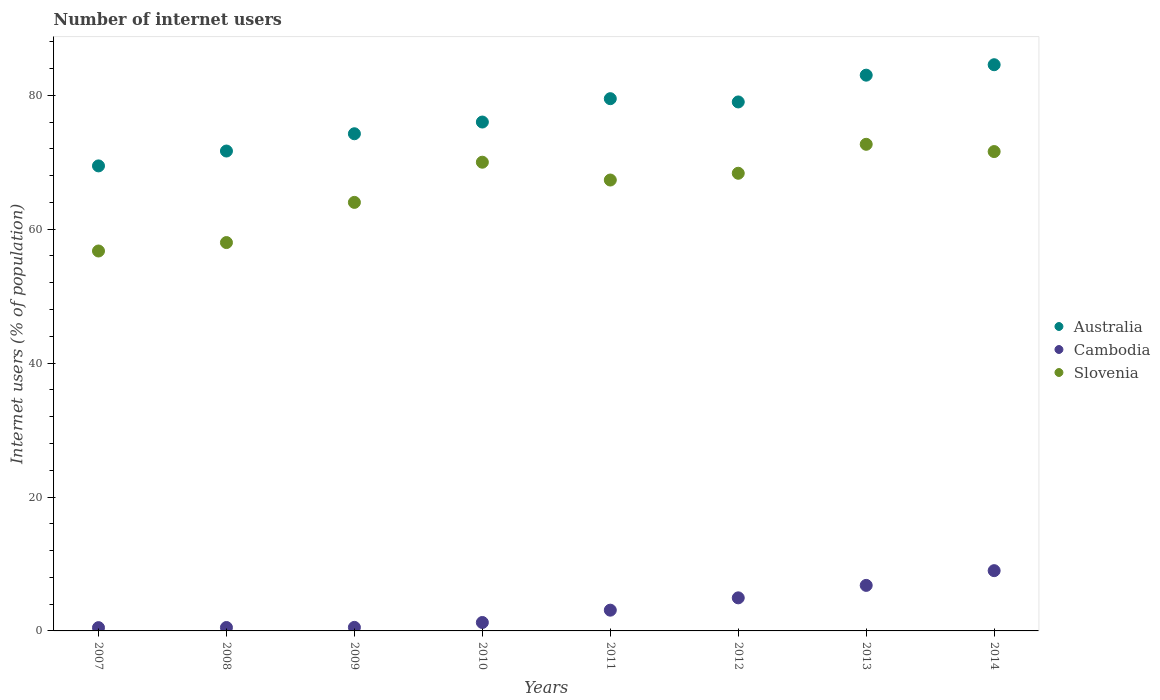Across all years, what is the maximum number of internet users in Australia?
Give a very brief answer. 84.56. Across all years, what is the minimum number of internet users in Cambodia?
Give a very brief answer. 0.49. In which year was the number of internet users in Cambodia maximum?
Your answer should be very brief. 2014. What is the total number of internet users in Cambodia in the graph?
Your response must be concise. 26.63. What is the difference between the number of internet users in Slovenia in 2011 and that in 2013?
Provide a short and direct response. -5.34. What is the difference between the number of internet users in Cambodia in 2007 and the number of internet users in Australia in 2008?
Provide a succinct answer. -71.18. What is the average number of internet users in Slovenia per year?
Your answer should be very brief. 66.09. In the year 2013, what is the difference between the number of internet users in Australia and number of internet users in Slovenia?
Offer a terse response. 10.32. What is the ratio of the number of internet users in Slovenia in 2010 to that in 2013?
Provide a short and direct response. 0.96. Is the number of internet users in Slovenia in 2008 less than that in 2009?
Keep it short and to the point. Yes. Is the difference between the number of internet users in Australia in 2010 and 2014 greater than the difference between the number of internet users in Slovenia in 2010 and 2014?
Offer a very short reply. No. What is the difference between the highest and the second highest number of internet users in Slovenia?
Make the answer very short. 1.09. What is the difference between the highest and the lowest number of internet users in Cambodia?
Your answer should be compact. 8.51. In how many years, is the number of internet users in Cambodia greater than the average number of internet users in Cambodia taken over all years?
Offer a terse response. 3. Is the sum of the number of internet users in Slovenia in 2013 and 2014 greater than the maximum number of internet users in Australia across all years?
Keep it short and to the point. Yes. Does the graph contain grids?
Provide a short and direct response. No. Where does the legend appear in the graph?
Offer a terse response. Center right. How many legend labels are there?
Make the answer very short. 3. What is the title of the graph?
Make the answer very short. Number of internet users. Does "Barbados" appear as one of the legend labels in the graph?
Provide a short and direct response. No. What is the label or title of the X-axis?
Your response must be concise. Years. What is the label or title of the Y-axis?
Ensure brevity in your answer.  Internet users (% of population). What is the Internet users (% of population) of Australia in 2007?
Your response must be concise. 69.45. What is the Internet users (% of population) of Cambodia in 2007?
Provide a short and direct response. 0.49. What is the Internet users (% of population) in Slovenia in 2007?
Give a very brief answer. 56.74. What is the Internet users (% of population) of Australia in 2008?
Provide a short and direct response. 71.67. What is the Internet users (% of population) in Cambodia in 2008?
Your answer should be compact. 0.51. What is the Internet users (% of population) of Slovenia in 2008?
Your answer should be very brief. 58. What is the Internet users (% of population) in Australia in 2009?
Provide a short and direct response. 74.25. What is the Internet users (% of population) of Cambodia in 2009?
Offer a very short reply. 0.53. What is the Internet users (% of population) in Slovenia in 2009?
Keep it short and to the point. 64. What is the Internet users (% of population) of Cambodia in 2010?
Give a very brief answer. 1.26. What is the Internet users (% of population) in Australia in 2011?
Offer a very short reply. 79.49. What is the Internet users (% of population) of Cambodia in 2011?
Make the answer very short. 3.1. What is the Internet users (% of population) of Slovenia in 2011?
Your answer should be compact. 67.34. What is the Internet users (% of population) of Australia in 2012?
Ensure brevity in your answer.  79. What is the Internet users (% of population) of Cambodia in 2012?
Keep it short and to the point. 4.94. What is the Internet users (% of population) of Slovenia in 2012?
Provide a succinct answer. 68.35. What is the Internet users (% of population) of Slovenia in 2013?
Your answer should be compact. 72.68. What is the Internet users (% of population) of Australia in 2014?
Your response must be concise. 84.56. What is the Internet users (% of population) in Cambodia in 2014?
Provide a short and direct response. 9. What is the Internet users (% of population) of Slovenia in 2014?
Your answer should be very brief. 71.59. Across all years, what is the maximum Internet users (% of population) of Australia?
Make the answer very short. 84.56. Across all years, what is the maximum Internet users (% of population) in Slovenia?
Offer a very short reply. 72.68. Across all years, what is the minimum Internet users (% of population) of Australia?
Provide a succinct answer. 69.45. Across all years, what is the minimum Internet users (% of population) in Cambodia?
Your answer should be very brief. 0.49. Across all years, what is the minimum Internet users (% of population) of Slovenia?
Provide a short and direct response. 56.74. What is the total Internet users (% of population) in Australia in the graph?
Provide a short and direct response. 617.42. What is the total Internet users (% of population) of Cambodia in the graph?
Offer a very short reply. 26.63. What is the total Internet users (% of population) in Slovenia in the graph?
Provide a short and direct response. 528.7. What is the difference between the Internet users (% of population) of Australia in 2007 and that in 2008?
Make the answer very short. -2.22. What is the difference between the Internet users (% of population) of Cambodia in 2007 and that in 2008?
Provide a short and direct response. -0.02. What is the difference between the Internet users (% of population) of Slovenia in 2007 and that in 2008?
Ensure brevity in your answer.  -1.26. What is the difference between the Internet users (% of population) in Australia in 2007 and that in 2009?
Make the answer very short. -4.8. What is the difference between the Internet users (% of population) of Cambodia in 2007 and that in 2009?
Provide a succinct answer. -0.04. What is the difference between the Internet users (% of population) in Slovenia in 2007 and that in 2009?
Ensure brevity in your answer.  -7.26. What is the difference between the Internet users (% of population) of Australia in 2007 and that in 2010?
Your response must be concise. -6.55. What is the difference between the Internet users (% of population) in Cambodia in 2007 and that in 2010?
Provide a succinct answer. -0.77. What is the difference between the Internet users (% of population) of Slovenia in 2007 and that in 2010?
Your answer should be very brief. -13.26. What is the difference between the Internet users (% of population) in Australia in 2007 and that in 2011?
Keep it short and to the point. -10.04. What is the difference between the Internet users (% of population) of Cambodia in 2007 and that in 2011?
Provide a short and direct response. -2.61. What is the difference between the Internet users (% of population) of Slovenia in 2007 and that in 2011?
Your answer should be very brief. -10.6. What is the difference between the Internet users (% of population) of Australia in 2007 and that in 2012?
Your answer should be very brief. -9.55. What is the difference between the Internet users (% of population) of Cambodia in 2007 and that in 2012?
Give a very brief answer. -4.45. What is the difference between the Internet users (% of population) in Slovenia in 2007 and that in 2012?
Your response must be concise. -11.61. What is the difference between the Internet users (% of population) in Australia in 2007 and that in 2013?
Provide a short and direct response. -13.55. What is the difference between the Internet users (% of population) of Cambodia in 2007 and that in 2013?
Your response must be concise. -6.31. What is the difference between the Internet users (% of population) in Slovenia in 2007 and that in 2013?
Ensure brevity in your answer.  -15.94. What is the difference between the Internet users (% of population) in Australia in 2007 and that in 2014?
Give a very brief answer. -15.11. What is the difference between the Internet users (% of population) in Cambodia in 2007 and that in 2014?
Provide a succinct answer. -8.51. What is the difference between the Internet users (% of population) of Slovenia in 2007 and that in 2014?
Give a very brief answer. -14.85. What is the difference between the Internet users (% of population) in Australia in 2008 and that in 2009?
Make the answer very short. -2.58. What is the difference between the Internet users (% of population) of Cambodia in 2008 and that in 2009?
Make the answer very short. -0.02. What is the difference between the Internet users (% of population) of Slovenia in 2008 and that in 2009?
Provide a short and direct response. -6. What is the difference between the Internet users (% of population) of Australia in 2008 and that in 2010?
Provide a succinct answer. -4.33. What is the difference between the Internet users (% of population) in Cambodia in 2008 and that in 2010?
Offer a terse response. -0.75. What is the difference between the Internet users (% of population) of Slovenia in 2008 and that in 2010?
Give a very brief answer. -12. What is the difference between the Internet users (% of population) of Australia in 2008 and that in 2011?
Keep it short and to the point. -7.82. What is the difference between the Internet users (% of population) of Cambodia in 2008 and that in 2011?
Ensure brevity in your answer.  -2.59. What is the difference between the Internet users (% of population) in Slovenia in 2008 and that in 2011?
Your answer should be compact. -9.34. What is the difference between the Internet users (% of population) in Australia in 2008 and that in 2012?
Your answer should be very brief. -7.33. What is the difference between the Internet users (% of population) of Cambodia in 2008 and that in 2012?
Offer a terse response. -4.43. What is the difference between the Internet users (% of population) in Slovenia in 2008 and that in 2012?
Offer a terse response. -10.35. What is the difference between the Internet users (% of population) in Australia in 2008 and that in 2013?
Offer a very short reply. -11.33. What is the difference between the Internet users (% of population) of Cambodia in 2008 and that in 2013?
Ensure brevity in your answer.  -6.29. What is the difference between the Internet users (% of population) of Slovenia in 2008 and that in 2013?
Ensure brevity in your answer.  -14.68. What is the difference between the Internet users (% of population) of Australia in 2008 and that in 2014?
Give a very brief answer. -12.89. What is the difference between the Internet users (% of population) in Cambodia in 2008 and that in 2014?
Give a very brief answer. -8.49. What is the difference between the Internet users (% of population) of Slovenia in 2008 and that in 2014?
Your response must be concise. -13.59. What is the difference between the Internet users (% of population) of Australia in 2009 and that in 2010?
Provide a succinct answer. -1.75. What is the difference between the Internet users (% of population) in Cambodia in 2009 and that in 2010?
Provide a succinct answer. -0.73. What is the difference between the Internet users (% of population) of Australia in 2009 and that in 2011?
Offer a terse response. -5.24. What is the difference between the Internet users (% of population) in Cambodia in 2009 and that in 2011?
Your response must be concise. -2.57. What is the difference between the Internet users (% of population) in Slovenia in 2009 and that in 2011?
Offer a very short reply. -3.34. What is the difference between the Internet users (% of population) in Australia in 2009 and that in 2012?
Give a very brief answer. -4.75. What is the difference between the Internet users (% of population) in Cambodia in 2009 and that in 2012?
Your response must be concise. -4.41. What is the difference between the Internet users (% of population) of Slovenia in 2009 and that in 2012?
Ensure brevity in your answer.  -4.35. What is the difference between the Internet users (% of population) of Australia in 2009 and that in 2013?
Your answer should be compact. -8.75. What is the difference between the Internet users (% of population) of Cambodia in 2009 and that in 2013?
Your answer should be very brief. -6.27. What is the difference between the Internet users (% of population) in Slovenia in 2009 and that in 2013?
Give a very brief answer. -8.68. What is the difference between the Internet users (% of population) of Australia in 2009 and that in 2014?
Keep it short and to the point. -10.31. What is the difference between the Internet users (% of population) in Cambodia in 2009 and that in 2014?
Keep it short and to the point. -8.47. What is the difference between the Internet users (% of population) in Slovenia in 2009 and that in 2014?
Offer a terse response. -7.59. What is the difference between the Internet users (% of population) of Australia in 2010 and that in 2011?
Provide a succinct answer. -3.49. What is the difference between the Internet users (% of population) in Cambodia in 2010 and that in 2011?
Your answer should be very brief. -1.84. What is the difference between the Internet users (% of population) of Slovenia in 2010 and that in 2011?
Offer a terse response. 2.66. What is the difference between the Internet users (% of population) of Australia in 2010 and that in 2012?
Provide a short and direct response. -3. What is the difference between the Internet users (% of population) in Cambodia in 2010 and that in 2012?
Make the answer very short. -3.68. What is the difference between the Internet users (% of population) of Slovenia in 2010 and that in 2012?
Provide a short and direct response. 1.65. What is the difference between the Internet users (% of population) in Cambodia in 2010 and that in 2013?
Your answer should be compact. -5.54. What is the difference between the Internet users (% of population) of Slovenia in 2010 and that in 2013?
Keep it short and to the point. -2.68. What is the difference between the Internet users (% of population) in Australia in 2010 and that in 2014?
Your answer should be very brief. -8.56. What is the difference between the Internet users (% of population) in Cambodia in 2010 and that in 2014?
Provide a succinct answer. -7.74. What is the difference between the Internet users (% of population) in Slovenia in 2010 and that in 2014?
Your answer should be compact. -1.59. What is the difference between the Internet users (% of population) of Australia in 2011 and that in 2012?
Ensure brevity in your answer.  0.49. What is the difference between the Internet users (% of population) of Cambodia in 2011 and that in 2012?
Your answer should be compact. -1.84. What is the difference between the Internet users (% of population) in Slovenia in 2011 and that in 2012?
Offer a very short reply. -1.01. What is the difference between the Internet users (% of population) of Australia in 2011 and that in 2013?
Your answer should be compact. -3.51. What is the difference between the Internet users (% of population) of Cambodia in 2011 and that in 2013?
Make the answer very short. -3.7. What is the difference between the Internet users (% of population) of Slovenia in 2011 and that in 2013?
Your answer should be very brief. -5.34. What is the difference between the Internet users (% of population) of Australia in 2011 and that in 2014?
Your answer should be compact. -5.07. What is the difference between the Internet users (% of population) in Slovenia in 2011 and that in 2014?
Make the answer very short. -4.25. What is the difference between the Internet users (% of population) in Cambodia in 2012 and that in 2013?
Make the answer very short. -1.86. What is the difference between the Internet users (% of population) in Slovenia in 2012 and that in 2013?
Your response must be concise. -4.33. What is the difference between the Internet users (% of population) in Australia in 2012 and that in 2014?
Give a very brief answer. -5.56. What is the difference between the Internet users (% of population) of Cambodia in 2012 and that in 2014?
Keep it short and to the point. -4.06. What is the difference between the Internet users (% of population) in Slovenia in 2012 and that in 2014?
Your response must be concise. -3.24. What is the difference between the Internet users (% of population) in Australia in 2013 and that in 2014?
Offer a very short reply. -1.56. What is the difference between the Internet users (% of population) in Slovenia in 2013 and that in 2014?
Keep it short and to the point. 1.09. What is the difference between the Internet users (% of population) of Australia in 2007 and the Internet users (% of population) of Cambodia in 2008?
Give a very brief answer. 68.94. What is the difference between the Internet users (% of population) in Australia in 2007 and the Internet users (% of population) in Slovenia in 2008?
Give a very brief answer. 11.45. What is the difference between the Internet users (% of population) of Cambodia in 2007 and the Internet users (% of population) of Slovenia in 2008?
Provide a succinct answer. -57.51. What is the difference between the Internet users (% of population) in Australia in 2007 and the Internet users (% of population) in Cambodia in 2009?
Your answer should be very brief. 68.92. What is the difference between the Internet users (% of population) of Australia in 2007 and the Internet users (% of population) of Slovenia in 2009?
Give a very brief answer. 5.45. What is the difference between the Internet users (% of population) in Cambodia in 2007 and the Internet users (% of population) in Slovenia in 2009?
Your answer should be compact. -63.51. What is the difference between the Internet users (% of population) of Australia in 2007 and the Internet users (% of population) of Cambodia in 2010?
Make the answer very short. 68.19. What is the difference between the Internet users (% of population) of Australia in 2007 and the Internet users (% of population) of Slovenia in 2010?
Offer a very short reply. -0.55. What is the difference between the Internet users (% of population) of Cambodia in 2007 and the Internet users (% of population) of Slovenia in 2010?
Provide a succinct answer. -69.51. What is the difference between the Internet users (% of population) of Australia in 2007 and the Internet users (% of population) of Cambodia in 2011?
Provide a short and direct response. 66.35. What is the difference between the Internet users (% of population) of Australia in 2007 and the Internet users (% of population) of Slovenia in 2011?
Keep it short and to the point. 2.11. What is the difference between the Internet users (% of population) in Cambodia in 2007 and the Internet users (% of population) in Slovenia in 2011?
Offer a very short reply. -66.85. What is the difference between the Internet users (% of population) in Australia in 2007 and the Internet users (% of population) in Cambodia in 2012?
Provide a succinct answer. 64.51. What is the difference between the Internet users (% of population) of Australia in 2007 and the Internet users (% of population) of Slovenia in 2012?
Make the answer very short. 1.1. What is the difference between the Internet users (% of population) in Cambodia in 2007 and the Internet users (% of population) in Slovenia in 2012?
Your answer should be very brief. -67.86. What is the difference between the Internet users (% of population) in Australia in 2007 and the Internet users (% of population) in Cambodia in 2013?
Offer a very short reply. 62.65. What is the difference between the Internet users (% of population) of Australia in 2007 and the Internet users (% of population) of Slovenia in 2013?
Your response must be concise. -3.23. What is the difference between the Internet users (% of population) of Cambodia in 2007 and the Internet users (% of population) of Slovenia in 2013?
Ensure brevity in your answer.  -72.19. What is the difference between the Internet users (% of population) of Australia in 2007 and the Internet users (% of population) of Cambodia in 2014?
Ensure brevity in your answer.  60.45. What is the difference between the Internet users (% of population) in Australia in 2007 and the Internet users (% of population) in Slovenia in 2014?
Ensure brevity in your answer.  -2.14. What is the difference between the Internet users (% of population) of Cambodia in 2007 and the Internet users (% of population) of Slovenia in 2014?
Your response must be concise. -71.1. What is the difference between the Internet users (% of population) of Australia in 2008 and the Internet users (% of population) of Cambodia in 2009?
Your answer should be compact. 71.14. What is the difference between the Internet users (% of population) in Australia in 2008 and the Internet users (% of population) in Slovenia in 2009?
Your response must be concise. 7.67. What is the difference between the Internet users (% of population) in Cambodia in 2008 and the Internet users (% of population) in Slovenia in 2009?
Your answer should be compact. -63.49. What is the difference between the Internet users (% of population) of Australia in 2008 and the Internet users (% of population) of Cambodia in 2010?
Make the answer very short. 70.41. What is the difference between the Internet users (% of population) of Australia in 2008 and the Internet users (% of population) of Slovenia in 2010?
Your answer should be compact. 1.67. What is the difference between the Internet users (% of population) of Cambodia in 2008 and the Internet users (% of population) of Slovenia in 2010?
Offer a very short reply. -69.49. What is the difference between the Internet users (% of population) in Australia in 2008 and the Internet users (% of population) in Cambodia in 2011?
Provide a succinct answer. 68.57. What is the difference between the Internet users (% of population) in Australia in 2008 and the Internet users (% of population) in Slovenia in 2011?
Your answer should be very brief. 4.33. What is the difference between the Internet users (% of population) in Cambodia in 2008 and the Internet users (% of population) in Slovenia in 2011?
Ensure brevity in your answer.  -66.83. What is the difference between the Internet users (% of population) of Australia in 2008 and the Internet users (% of population) of Cambodia in 2012?
Offer a terse response. 66.73. What is the difference between the Internet users (% of population) in Australia in 2008 and the Internet users (% of population) in Slovenia in 2012?
Give a very brief answer. 3.32. What is the difference between the Internet users (% of population) in Cambodia in 2008 and the Internet users (% of population) in Slovenia in 2012?
Provide a short and direct response. -67.84. What is the difference between the Internet users (% of population) of Australia in 2008 and the Internet users (% of population) of Cambodia in 2013?
Offer a terse response. 64.87. What is the difference between the Internet users (% of population) of Australia in 2008 and the Internet users (% of population) of Slovenia in 2013?
Your answer should be compact. -1.01. What is the difference between the Internet users (% of population) of Cambodia in 2008 and the Internet users (% of population) of Slovenia in 2013?
Your answer should be very brief. -72.17. What is the difference between the Internet users (% of population) in Australia in 2008 and the Internet users (% of population) in Cambodia in 2014?
Provide a succinct answer. 62.67. What is the difference between the Internet users (% of population) in Cambodia in 2008 and the Internet users (% of population) in Slovenia in 2014?
Your answer should be very brief. -71.08. What is the difference between the Internet users (% of population) of Australia in 2009 and the Internet users (% of population) of Cambodia in 2010?
Offer a very short reply. 72.99. What is the difference between the Internet users (% of population) of Australia in 2009 and the Internet users (% of population) of Slovenia in 2010?
Your answer should be compact. 4.25. What is the difference between the Internet users (% of population) in Cambodia in 2009 and the Internet users (% of population) in Slovenia in 2010?
Offer a terse response. -69.47. What is the difference between the Internet users (% of population) of Australia in 2009 and the Internet users (% of population) of Cambodia in 2011?
Keep it short and to the point. 71.15. What is the difference between the Internet users (% of population) of Australia in 2009 and the Internet users (% of population) of Slovenia in 2011?
Your answer should be very brief. 6.91. What is the difference between the Internet users (% of population) in Cambodia in 2009 and the Internet users (% of population) in Slovenia in 2011?
Ensure brevity in your answer.  -66.81. What is the difference between the Internet users (% of population) in Australia in 2009 and the Internet users (% of population) in Cambodia in 2012?
Your answer should be compact. 69.31. What is the difference between the Internet users (% of population) in Cambodia in 2009 and the Internet users (% of population) in Slovenia in 2012?
Provide a succinct answer. -67.82. What is the difference between the Internet users (% of population) in Australia in 2009 and the Internet users (% of population) in Cambodia in 2013?
Offer a terse response. 67.45. What is the difference between the Internet users (% of population) in Australia in 2009 and the Internet users (% of population) in Slovenia in 2013?
Offer a very short reply. 1.57. What is the difference between the Internet users (% of population) in Cambodia in 2009 and the Internet users (% of population) in Slovenia in 2013?
Your answer should be very brief. -72.15. What is the difference between the Internet users (% of population) of Australia in 2009 and the Internet users (% of population) of Cambodia in 2014?
Make the answer very short. 65.25. What is the difference between the Internet users (% of population) in Australia in 2009 and the Internet users (% of population) in Slovenia in 2014?
Your answer should be very brief. 2.66. What is the difference between the Internet users (% of population) in Cambodia in 2009 and the Internet users (% of population) in Slovenia in 2014?
Offer a terse response. -71.06. What is the difference between the Internet users (% of population) of Australia in 2010 and the Internet users (% of population) of Cambodia in 2011?
Your response must be concise. 72.9. What is the difference between the Internet users (% of population) in Australia in 2010 and the Internet users (% of population) in Slovenia in 2011?
Your answer should be compact. 8.66. What is the difference between the Internet users (% of population) in Cambodia in 2010 and the Internet users (% of population) in Slovenia in 2011?
Ensure brevity in your answer.  -66.08. What is the difference between the Internet users (% of population) in Australia in 2010 and the Internet users (% of population) in Cambodia in 2012?
Keep it short and to the point. 71.06. What is the difference between the Internet users (% of population) of Australia in 2010 and the Internet users (% of population) of Slovenia in 2012?
Give a very brief answer. 7.65. What is the difference between the Internet users (% of population) of Cambodia in 2010 and the Internet users (% of population) of Slovenia in 2012?
Offer a terse response. -67.09. What is the difference between the Internet users (% of population) in Australia in 2010 and the Internet users (% of population) in Cambodia in 2013?
Offer a terse response. 69.2. What is the difference between the Internet users (% of population) in Australia in 2010 and the Internet users (% of population) in Slovenia in 2013?
Your answer should be compact. 3.32. What is the difference between the Internet users (% of population) of Cambodia in 2010 and the Internet users (% of population) of Slovenia in 2013?
Offer a terse response. -71.42. What is the difference between the Internet users (% of population) of Australia in 2010 and the Internet users (% of population) of Slovenia in 2014?
Make the answer very short. 4.41. What is the difference between the Internet users (% of population) of Cambodia in 2010 and the Internet users (% of population) of Slovenia in 2014?
Your response must be concise. -70.33. What is the difference between the Internet users (% of population) of Australia in 2011 and the Internet users (% of population) of Cambodia in 2012?
Your answer should be compact. 74.55. What is the difference between the Internet users (% of population) in Australia in 2011 and the Internet users (% of population) in Slovenia in 2012?
Keep it short and to the point. 11.14. What is the difference between the Internet users (% of population) in Cambodia in 2011 and the Internet users (% of population) in Slovenia in 2012?
Provide a succinct answer. -65.25. What is the difference between the Internet users (% of population) in Australia in 2011 and the Internet users (% of population) in Cambodia in 2013?
Offer a terse response. 72.69. What is the difference between the Internet users (% of population) in Australia in 2011 and the Internet users (% of population) in Slovenia in 2013?
Your answer should be very brief. 6.81. What is the difference between the Internet users (% of population) in Cambodia in 2011 and the Internet users (% of population) in Slovenia in 2013?
Ensure brevity in your answer.  -69.58. What is the difference between the Internet users (% of population) in Australia in 2011 and the Internet users (% of population) in Cambodia in 2014?
Keep it short and to the point. 70.49. What is the difference between the Internet users (% of population) of Australia in 2011 and the Internet users (% of population) of Slovenia in 2014?
Your answer should be compact. 7.9. What is the difference between the Internet users (% of population) in Cambodia in 2011 and the Internet users (% of population) in Slovenia in 2014?
Keep it short and to the point. -68.49. What is the difference between the Internet users (% of population) of Australia in 2012 and the Internet users (% of population) of Cambodia in 2013?
Give a very brief answer. 72.2. What is the difference between the Internet users (% of population) in Australia in 2012 and the Internet users (% of population) in Slovenia in 2013?
Offer a very short reply. 6.32. What is the difference between the Internet users (% of population) of Cambodia in 2012 and the Internet users (% of population) of Slovenia in 2013?
Provide a succinct answer. -67.74. What is the difference between the Internet users (% of population) of Australia in 2012 and the Internet users (% of population) of Slovenia in 2014?
Offer a very short reply. 7.41. What is the difference between the Internet users (% of population) in Cambodia in 2012 and the Internet users (% of population) in Slovenia in 2014?
Keep it short and to the point. -66.65. What is the difference between the Internet users (% of population) of Australia in 2013 and the Internet users (% of population) of Slovenia in 2014?
Give a very brief answer. 11.41. What is the difference between the Internet users (% of population) in Cambodia in 2013 and the Internet users (% of population) in Slovenia in 2014?
Offer a terse response. -64.79. What is the average Internet users (% of population) in Australia per year?
Make the answer very short. 77.18. What is the average Internet users (% of population) in Cambodia per year?
Keep it short and to the point. 3.33. What is the average Internet users (% of population) in Slovenia per year?
Provide a short and direct response. 66.09. In the year 2007, what is the difference between the Internet users (% of population) in Australia and Internet users (% of population) in Cambodia?
Give a very brief answer. 68.96. In the year 2007, what is the difference between the Internet users (% of population) of Australia and Internet users (% of population) of Slovenia?
Provide a succinct answer. 12.71. In the year 2007, what is the difference between the Internet users (% of population) of Cambodia and Internet users (% of population) of Slovenia?
Your response must be concise. -56.25. In the year 2008, what is the difference between the Internet users (% of population) in Australia and Internet users (% of population) in Cambodia?
Make the answer very short. 71.16. In the year 2008, what is the difference between the Internet users (% of population) of Australia and Internet users (% of population) of Slovenia?
Your answer should be compact. 13.67. In the year 2008, what is the difference between the Internet users (% of population) in Cambodia and Internet users (% of population) in Slovenia?
Ensure brevity in your answer.  -57.49. In the year 2009, what is the difference between the Internet users (% of population) in Australia and Internet users (% of population) in Cambodia?
Offer a terse response. 73.72. In the year 2009, what is the difference between the Internet users (% of population) in Australia and Internet users (% of population) in Slovenia?
Your response must be concise. 10.25. In the year 2009, what is the difference between the Internet users (% of population) in Cambodia and Internet users (% of population) in Slovenia?
Keep it short and to the point. -63.47. In the year 2010, what is the difference between the Internet users (% of population) in Australia and Internet users (% of population) in Cambodia?
Give a very brief answer. 74.74. In the year 2010, what is the difference between the Internet users (% of population) in Australia and Internet users (% of population) in Slovenia?
Offer a very short reply. 6. In the year 2010, what is the difference between the Internet users (% of population) of Cambodia and Internet users (% of population) of Slovenia?
Offer a very short reply. -68.74. In the year 2011, what is the difference between the Internet users (% of population) in Australia and Internet users (% of population) in Cambodia?
Keep it short and to the point. 76.39. In the year 2011, what is the difference between the Internet users (% of population) of Australia and Internet users (% of population) of Slovenia?
Offer a very short reply. 12.15. In the year 2011, what is the difference between the Internet users (% of population) of Cambodia and Internet users (% of population) of Slovenia?
Keep it short and to the point. -64.24. In the year 2012, what is the difference between the Internet users (% of population) of Australia and Internet users (% of population) of Cambodia?
Offer a terse response. 74.06. In the year 2012, what is the difference between the Internet users (% of population) of Australia and Internet users (% of population) of Slovenia?
Give a very brief answer. 10.65. In the year 2012, what is the difference between the Internet users (% of population) of Cambodia and Internet users (% of population) of Slovenia?
Offer a very short reply. -63.41. In the year 2013, what is the difference between the Internet users (% of population) in Australia and Internet users (% of population) in Cambodia?
Offer a terse response. 76.2. In the year 2013, what is the difference between the Internet users (% of population) in Australia and Internet users (% of population) in Slovenia?
Your answer should be compact. 10.32. In the year 2013, what is the difference between the Internet users (% of population) of Cambodia and Internet users (% of population) of Slovenia?
Make the answer very short. -65.88. In the year 2014, what is the difference between the Internet users (% of population) in Australia and Internet users (% of population) in Cambodia?
Offer a terse response. 75.56. In the year 2014, what is the difference between the Internet users (% of population) of Australia and Internet users (% of population) of Slovenia?
Provide a short and direct response. 12.97. In the year 2014, what is the difference between the Internet users (% of population) of Cambodia and Internet users (% of population) of Slovenia?
Provide a succinct answer. -62.59. What is the ratio of the Internet users (% of population) of Australia in 2007 to that in 2008?
Provide a short and direct response. 0.97. What is the ratio of the Internet users (% of population) of Cambodia in 2007 to that in 2008?
Provide a succinct answer. 0.96. What is the ratio of the Internet users (% of population) in Slovenia in 2007 to that in 2008?
Provide a succinct answer. 0.98. What is the ratio of the Internet users (% of population) in Australia in 2007 to that in 2009?
Your answer should be very brief. 0.94. What is the ratio of the Internet users (% of population) of Cambodia in 2007 to that in 2009?
Provide a short and direct response. 0.92. What is the ratio of the Internet users (% of population) of Slovenia in 2007 to that in 2009?
Make the answer very short. 0.89. What is the ratio of the Internet users (% of population) of Australia in 2007 to that in 2010?
Ensure brevity in your answer.  0.91. What is the ratio of the Internet users (% of population) of Cambodia in 2007 to that in 2010?
Offer a very short reply. 0.39. What is the ratio of the Internet users (% of population) in Slovenia in 2007 to that in 2010?
Give a very brief answer. 0.81. What is the ratio of the Internet users (% of population) of Australia in 2007 to that in 2011?
Offer a very short reply. 0.87. What is the ratio of the Internet users (% of population) of Cambodia in 2007 to that in 2011?
Offer a very short reply. 0.16. What is the ratio of the Internet users (% of population) of Slovenia in 2007 to that in 2011?
Your answer should be very brief. 0.84. What is the ratio of the Internet users (% of population) in Australia in 2007 to that in 2012?
Give a very brief answer. 0.88. What is the ratio of the Internet users (% of population) of Cambodia in 2007 to that in 2012?
Keep it short and to the point. 0.1. What is the ratio of the Internet users (% of population) in Slovenia in 2007 to that in 2012?
Your response must be concise. 0.83. What is the ratio of the Internet users (% of population) of Australia in 2007 to that in 2013?
Offer a very short reply. 0.84. What is the ratio of the Internet users (% of population) of Cambodia in 2007 to that in 2013?
Keep it short and to the point. 0.07. What is the ratio of the Internet users (% of population) in Slovenia in 2007 to that in 2013?
Keep it short and to the point. 0.78. What is the ratio of the Internet users (% of population) in Australia in 2007 to that in 2014?
Your response must be concise. 0.82. What is the ratio of the Internet users (% of population) in Cambodia in 2007 to that in 2014?
Your answer should be compact. 0.05. What is the ratio of the Internet users (% of population) in Slovenia in 2007 to that in 2014?
Your response must be concise. 0.79. What is the ratio of the Internet users (% of population) in Australia in 2008 to that in 2009?
Offer a terse response. 0.97. What is the ratio of the Internet users (% of population) in Cambodia in 2008 to that in 2009?
Your response must be concise. 0.96. What is the ratio of the Internet users (% of population) in Slovenia in 2008 to that in 2009?
Your response must be concise. 0.91. What is the ratio of the Internet users (% of population) in Australia in 2008 to that in 2010?
Ensure brevity in your answer.  0.94. What is the ratio of the Internet users (% of population) in Cambodia in 2008 to that in 2010?
Give a very brief answer. 0.4. What is the ratio of the Internet users (% of population) of Slovenia in 2008 to that in 2010?
Give a very brief answer. 0.83. What is the ratio of the Internet users (% of population) in Australia in 2008 to that in 2011?
Keep it short and to the point. 0.9. What is the ratio of the Internet users (% of population) in Cambodia in 2008 to that in 2011?
Ensure brevity in your answer.  0.16. What is the ratio of the Internet users (% of population) of Slovenia in 2008 to that in 2011?
Keep it short and to the point. 0.86. What is the ratio of the Internet users (% of population) of Australia in 2008 to that in 2012?
Your answer should be compact. 0.91. What is the ratio of the Internet users (% of population) in Cambodia in 2008 to that in 2012?
Your response must be concise. 0.1. What is the ratio of the Internet users (% of population) in Slovenia in 2008 to that in 2012?
Keep it short and to the point. 0.85. What is the ratio of the Internet users (% of population) in Australia in 2008 to that in 2013?
Your answer should be compact. 0.86. What is the ratio of the Internet users (% of population) in Cambodia in 2008 to that in 2013?
Give a very brief answer. 0.07. What is the ratio of the Internet users (% of population) of Slovenia in 2008 to that in 2013?
Offer a terse response. 0.8. What is the ratio of the Internet users (% of population) of Australia in 2008 to that in 2014?
Offer a terse response. 0.85. What is the ratio of the Internet users (% of population) in Cambodia in 2008 to that in 2014?
Make the answer very short. 0.06. What is the ratio of the Internet users (% of population) of Slovenia in 2008 to that in 2014?
Keep it short and to the point. 0.81. What is the ratio of the Internet users (% of population) of Australia in 2009 to that in 2010?
Your response must be concise. 0.98. What is the ratio of the Internet users (% of population) in Cambodia in 2009 to that in 2010?
Your response must be concise. 0.42. What is the ratio of the Internet users (% of population) of Slovenia in 2009 to that in 2010?
Offer a very short reply. 0.91. What is the ratio of the Internet users (% of population) in Australia in 2009 to that in 2011?
Your answer should be compact. 0.93. What is the ratio of the Internet users (% of population) in Cambodia in 2009 to that in 2011?
Provide a short and direct response. 0.17. What is the ratio of the Internet users (% of population) in Slovenia in 2009 to that in 2011?
Offer a very short reply. 0.95. What is the ratio of the Internet users (% of population) of Australia in 2009 to that in 2012?
Make the answer very short. 0.94. What is the ratio of the Internet users (% of population) of Cambodia in 2009 to that in 2012?
Provide a succinct answer. 0.11. What is the ratio of the Internet users (% of population) in Slovenia in 2009 to that in 2012?
Your answer should be compact. 0.94. What is the ratio of the Internet users (% of population) of Australia in 2009 to that in 2013?
Your response must be concise. 0.89. What is the ratio of the Internet users (% of population) of Cambodia in 2009 to that in 2013?
Make the answer very short. 0.08. What is the ratio of the Internet users (% of population) in Slovenia in 2009 to that in 2013?
Give a very brief answer. 0.88. What is the ratio of the Internet users (% of population) in Australia in 2009 to that in 2014?
Make the answer very short. 0.88. What is the ratio of the Internet users (% of population) in Cambodia in 2009 to that in 2014?
Offer a terse response. 0.06. What is the ratio of the Internet users (% of population) in Slovenia in 2009 to that in 2014?
Your answer should be very brief. 0.89. What is the ratio of the Internet users (% of population) in Australia in 2010 to that in 2011?
Your answer should be compact. 0.96. What is the ratio of the Internet users (% of population) of Cambodia in 2010 to that in 2011?
Provide a short and direct response. 0.41. What is the ratio of the Internet users (% of population) in Slovenia in 2010 to that in 2011?
Your answer should be compact. 1.04. What is the ratio of the Internet users (% of population) in Cambodia in 2010 to that in 2012?
Provide a succinct answer. 0.26. What is the ratio of the Internet users (% of population) of Slovenia in 2010 to that in 2012?
Provide a succinct answer. 1.02. What is the ratio of the Internet users (% of population) in Australia in 2010 to that in 2013?
Ensure brevity in your answer.  0.92. What is the ratio of the Internet users (% of population) in Cambodia in 2010 to that in 2013?
Make the answer very short. 0.19. What is the ratio of the Internet users (% of population) of Slovenia in 2010 to that in 2013?
Make the answer very short. 0.96. What is the ratio of the Internet users (% of population) of Australia in 2010 to that in 2014?
Your answer should be compact. 0.9. What is the ratio of the Internet users (% of population) of Cambodia in 2010 to that in 2014?
Provide a short and direct response. 0.14. What is the ratio of the Internet users (% of population) in Slovenia in 2010 to that in 2014?
Your response must be concise. 0.98. What is the ratio of the Internet users (% of population) in Cambodia in 2011 to that in 2012?
Make the answer very short. 0.63. What is the ratio of the Internet users (% of population) in Slovenia in 2011 to that in 2012?
Provide a succinct answer. 0.99. What is the ratio of the Internet users (% of population) of Australia in 2011 to that in 2013?
Offer a terse response. 0.96. What is the ratio of the Internet users (% of population) of Cambodia in 2011 to that in 2013?
Keep it short and to the point. 0.46. What is the ratio of the Internet users (% of population) in Slovenia in 2011 to that in 2013?
Make the answer very short. 0.93. What is the ratio of the Internet users (% of population) of Cambodia in 2011 to that in 2014?
Your answer should be compact. 0.34. What is the ratio of the Internet users (% of population) in Slovenia in 2011 to that in 2014?
Ensure brevity in your answer.  0.94. What is the ratio of the Internet users (% of population) of Australia in 2012 to that in 2013?
Make the answer very short. 0.95. What is the ratio of the Internet users (% of population) of Cambodia in 2012 to that in 2013?
Provide a succinct answer. 0.73. What is the ratio of the Internet users (% of population) in Slovenia in 2012 to that in 2013?
Your answer should be very brief. 0.94. What is the ratio of the Internet users (% of population) of Australia in 2012 to that in 2014?
Offer a very short reply. 0.93. What is the ratio of the Internet users (% of population) of Cambodia in 2012 to that in 2014?
Your answer should be very brief. 0.55. What is the ratio of the Internet users (% of population) of Slovenia in 2012 to that in 2014?
Your answer should be compact. 0.95. What is the ratio of the Internet users (% of population) of Australia in 2013 to that in 2014?
Offer a terse response. 0.98. What is the ratio of the Internet users (% of population) of Cambodia in 2013 to that in 2014?
Keep it short and to the point. 0.76. What is the ratio of the Internet users (% of population) in Slovenia in 2013 to that in 2014?
Your answer should be very brief. 1.02. What is the difference between the highest and the second highest Internet users (% of population) in Australia?
Give a very brief answer. 1.56. What is the difference between the highest and the second highest Internet users (% of population) of Slovenia?
Provide a short and direct response. 1.09. What is the difference between the highest and the lowest Internet users (% of population) of Australia?
Your answer should be very brief. 15.11. What is the difference between the highest and the lowest Internet users (% of population) of Cambodia?
Your response must be concise. 8.51. What is the difference between the highest and the lowest Internet users (% of population) of Slovenia?
Your answer should be compact. 15.94. 